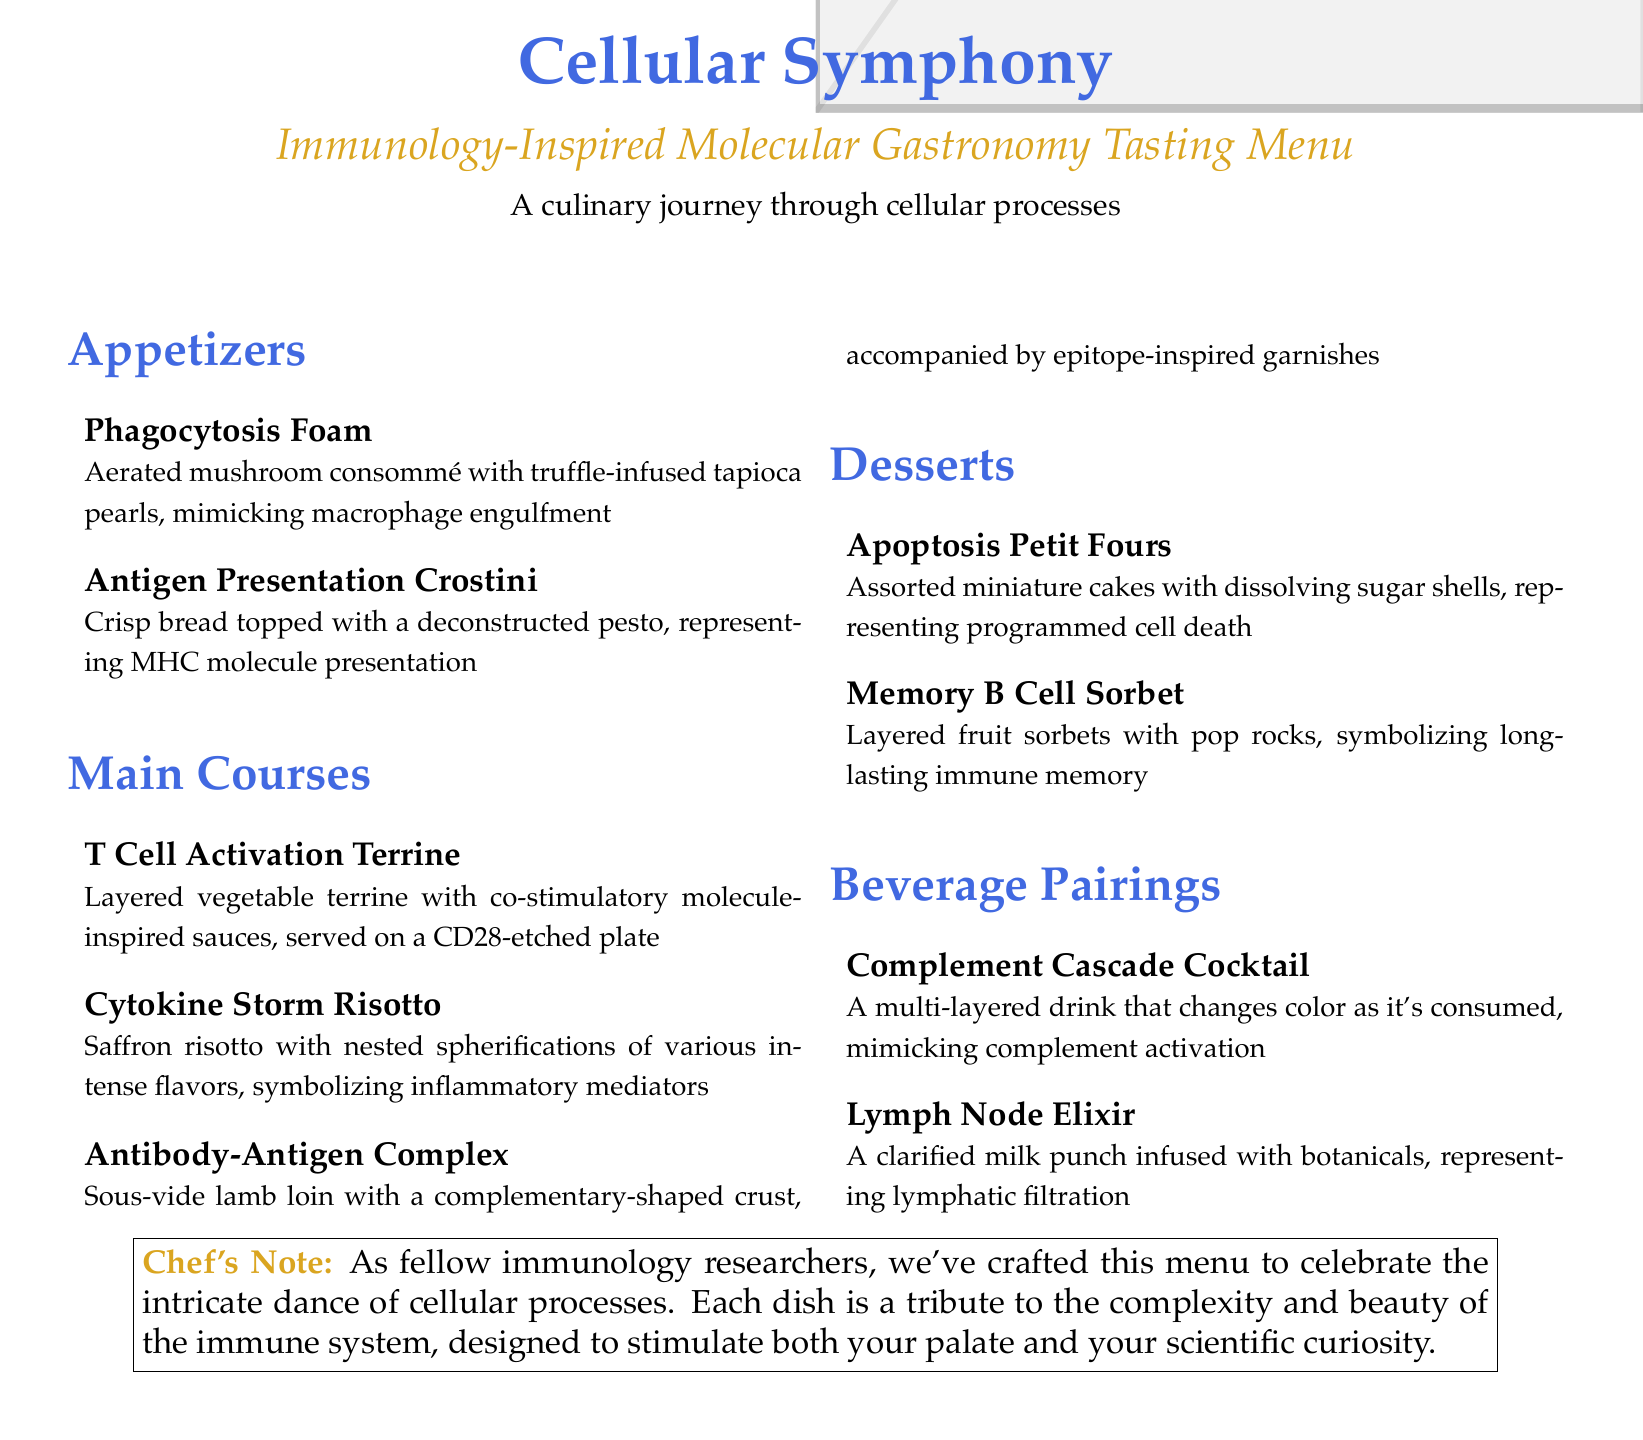What is the name of the menu? The title presented at the top of the document indicates the name of the menu.
Answer: Cellular Symphony How many appetizers are listed? The document lists items in the appetizers section, which need to be counted.
Answer: 2 What is the first main course dish? The document specifies the order of the dishes, with the first one clearly stated.
Answer: T Cell Activation Terrine What unique feature does the Complement Cascade Cocktail have? The description of the beverage details its characteristics, including its visual aspect during consumption.
Answer: Changes color What do the Apoptosis Petit Fours represent? The dish description provides a conceptual metaphor for the plating and presentation, relating it to a cellular process.
Answer: Programmed cell death How many desserts are offered? The desserts section lists specific items, which can be enumerated.
Answer: 2 What ingredient is highlighted in the Memory B Cell Sorbet? The description emphasizes a particular characteristic of the dessert that represents immune memory.
Answer: Pop rocks Which dish is associated with macrophage activity? The appetizer section specifically names a dish linked to this immune process through its description.
Answer: Phagocytosis Foam What is the theme of the beverage pairings? The titles and descriptions suggest a unifying concept related to immunology.
Answer: Lymphatic filtration 